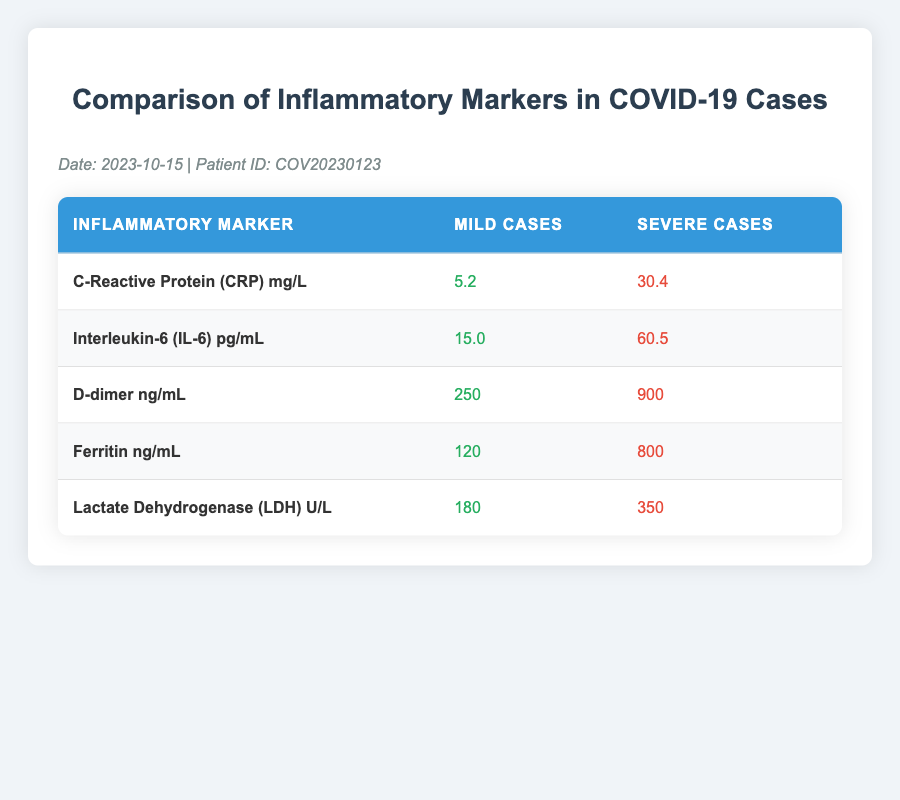What is the C-Reactive Protein (CRP) level in mild COVID-19 cases? The table shows the value for C-Reactive Protein (CRP) in mild cases as 5.2 mg/L.
Answer: 5.2 mg/L What is the D-dimer level in severe COVID-19 cases? The table indicates that the D-dimer level in severe cases is 900 ng/mL.
Answer: 900 ng/mL Is the Interleukin-6 (IL-6) level higher in severe cases compared to mild cases? The IL-6 levels are 60.5 pg/mL for severe cases and 15.0 pg/mL for mild cases, confirming that it is indeed higher in severe cases.
Answer: Yes What is the difference in Ferritin levels between severe and mild COVID-19 cases? To find the difference, subtract the mild Ferritin level of 120 ng/mL from the severe level of 800 ng/mL, resulting in a difference of 800 - 120 = 680 ng/mL.
Answer: 680 ng/mL What is the average Lactate Dehydrogenase (LDH) level for both mild and severe cases? The LDH levels are 180 U/L for mild cases and 350 U/L for severe cases. First, add these two values: 180 + 350 = 530 U/L. Then, divide by 2 to calculate the average: 530 / 2 = 265 U/L.
Answer: 265 U/L Is the CRP level in mild COVID-19 cases greater than 10 mg/L? The table shows the mild CRP level is 5.2 mg/L, which is less than 10 mg/L. Thus, the statement is false.
Answer: No What is the highest inflammatory marker value recorded in severe cases? By inspecting the values in the table for severe cases, the highest value is the Ferritin level of 800 ng/mL.
Answer: 800 ng/mL What is the total of Interleukin-6 (IL-6) levels from both mild and severe cases? Add the IL-6 level from mild cases (15.0 pg/mL) and severe cases (60.5 pg/mL): 15.0 + 60.5 = 75.5 pg/mL.
Answer: 75.5 pg/mL What inflammatory marker in severe cases has the largest gap when compared to its mild counterpart? Comparing the differences: CRP (30.4 - 5.2 = 25.2), IL-6 (60.5 - 15.0 = 45.5), D-dimer (900 - 250 = 650), Ferritin (800 - 120 = 680), LDH (350 - 180 = 170). The largest gap is in Ferritin, which is 680 ng/mL.
Answer: Ferritin 